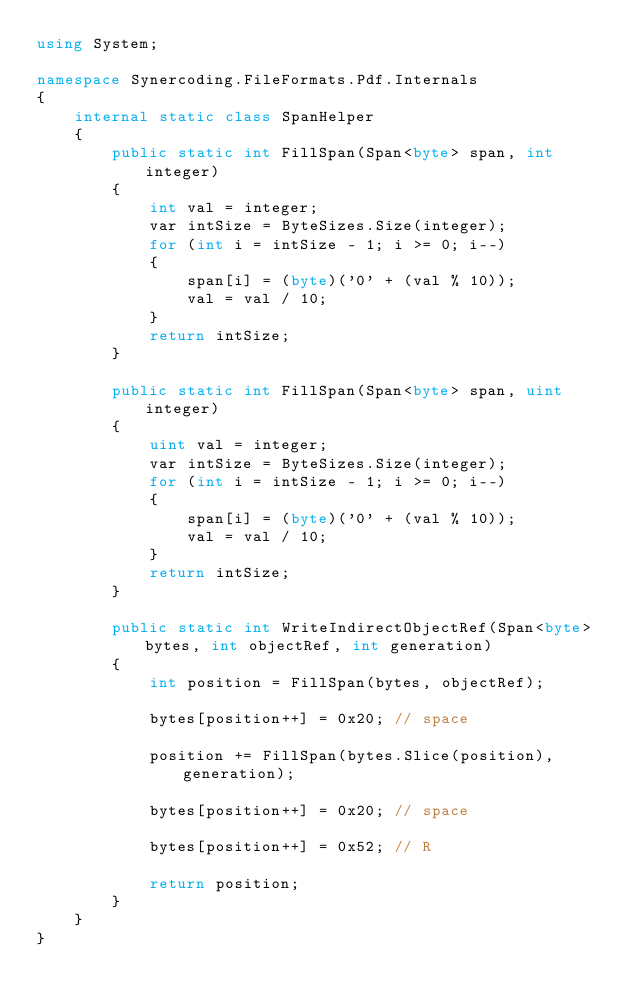<code> <loc_0><loc_0><loc_500><loc_500><_C#_>using System;

namespace Synercoding.FileFormats.Pdf.Internals
{
    internal static class SpanHelper
    {
        public static int FillSpan(Span<byte> span, int integer)
        {
            int val = integer;
            var intSize = ByteSizes.Size(integer);
            for (int i = intSize - 1; i >= 0; i--)
            {
                span[i] = (byte)('0' + (val % 10));
                val = val / 10;
            }
            return intSize;
        }

        public static int FillSpan(Span<byte> span, uint integer)
        {
            uint val = integer;
            var intSize = ByteSizes.Size(integer);
            for (int i = intSize - 1; i >= 0; i--)
            {
                span[i] = (byte)('0' + (val % 10));
                val = val / 10;
            }
            return intSize;
        }

        public static int WriteIndirectObjectRef(Span<byte> bytes, int objectRef, int generation)
        {
            int position = FillSpan(bytes, objectRef);

            bytes[position++] = 0x20; // space

            position += FillSpan(bytes.Slice(position), generation);

            bytes[position++] = 0x20; // space

            bytes[position++] = 0x52; // R

            return position;
        }
    }
}
</code> 